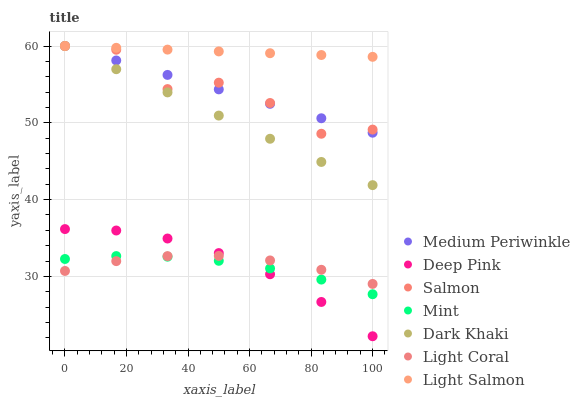Does Mint have the minimum area under the curve?
Answer yes or no. Yes. Does Light Salmon have the maximum area under the curve?
Answer yes or no. Yes. Does Deep Pink have the minimum area under the curve?
Answer yes or no. No. Does Deep Pink have the maximum area under the curve?
Answer yes or no. No. Is Dark Khaki the smoothest?
Answer yes or no. Yes. Is Salmon the roughest?
Answer yes or no. Yes. Is Light Salmon the smoothest?
Answer yes or no. No. Is Light Salmon the roughest?
Answer yes or no. No. Does Deep Pink have the lowest value?
Answer yes or no. Yes. Does Light Salmon have the lowest value?
Answer yes or no. No. Does Dark Khaki have the highest value?
Answer yes or no. Yes. Does Deep Pink have the highest value?
Answer yes or no. No. Is Light Coral less than Dark Khaki?
Answer yes or no. Yes. Is Light Salmon greater than Light Coral?
Answer yes or no. Yes. Does Dark Khaki intersect Salmon?
Answer yes or no. Yes. Is Dark Khaki less than Salmon?
Answer yes or no. No. Is Dark Khaki greater than Salmon?
Answer yes or no. No. Does Light Coral intersect Dark Khaki?
Answer yes or no. No. 